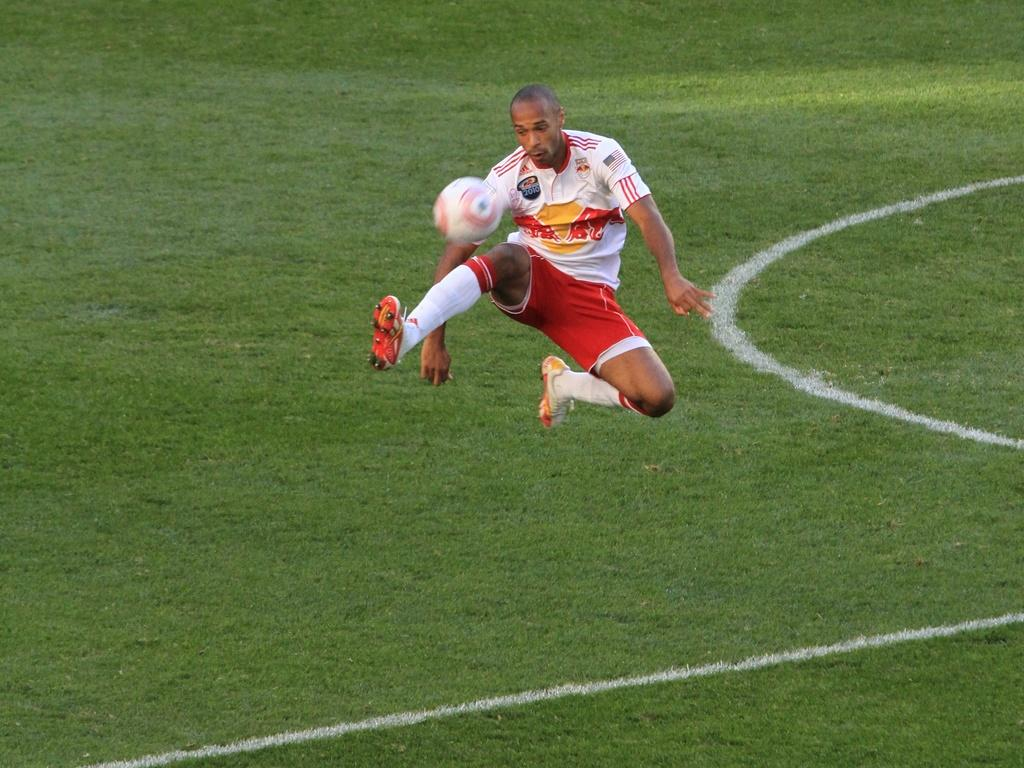What is the main subject of the image? There is a person in the image. What is the person wearing on their upper body? The person is wearing a white T-shirt. What type of footwear is the person wearing? The person is wearing shoes. What is the person doing in the image? The person is in the air. What else is in the air besides the person? There is a ball in the air. What can be seen below the person in the image? The ground is visible in the image. What type of patch can be seen on the person's elbow in the image? There is no patch visible on the person's elbow in the image, as the person is wearing a white T-shirt and the elbow is not visible. 